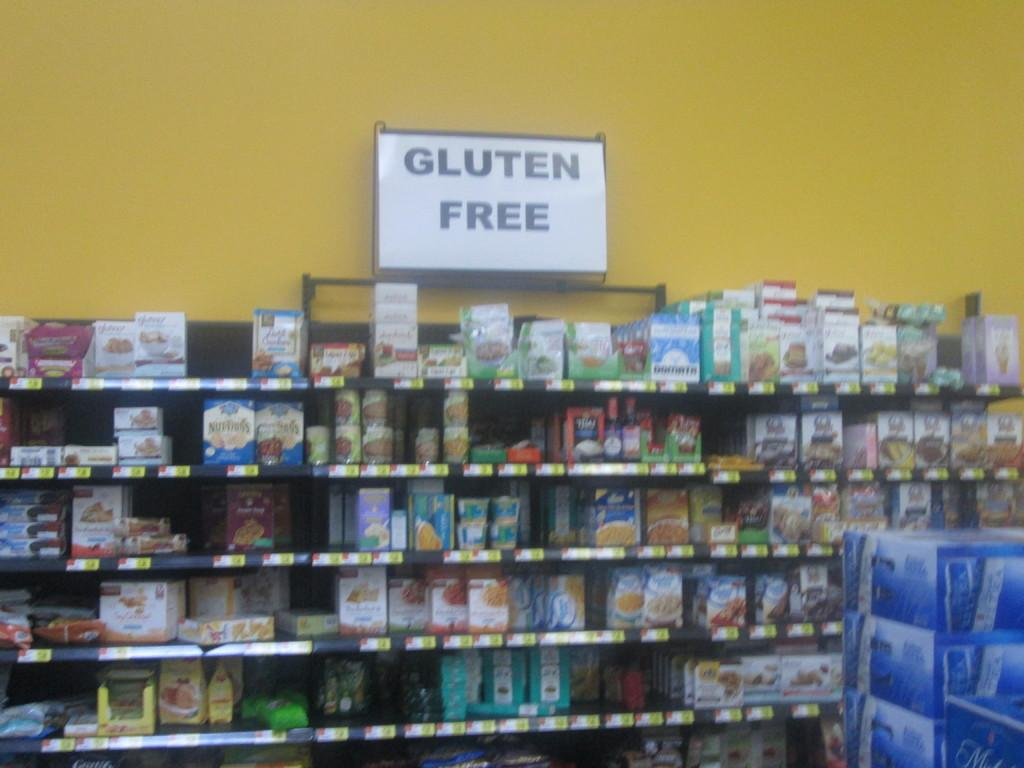<image>
Give a short and clear explanation of the subsequent image. A section of a store is shown that contains gluten free goods. 